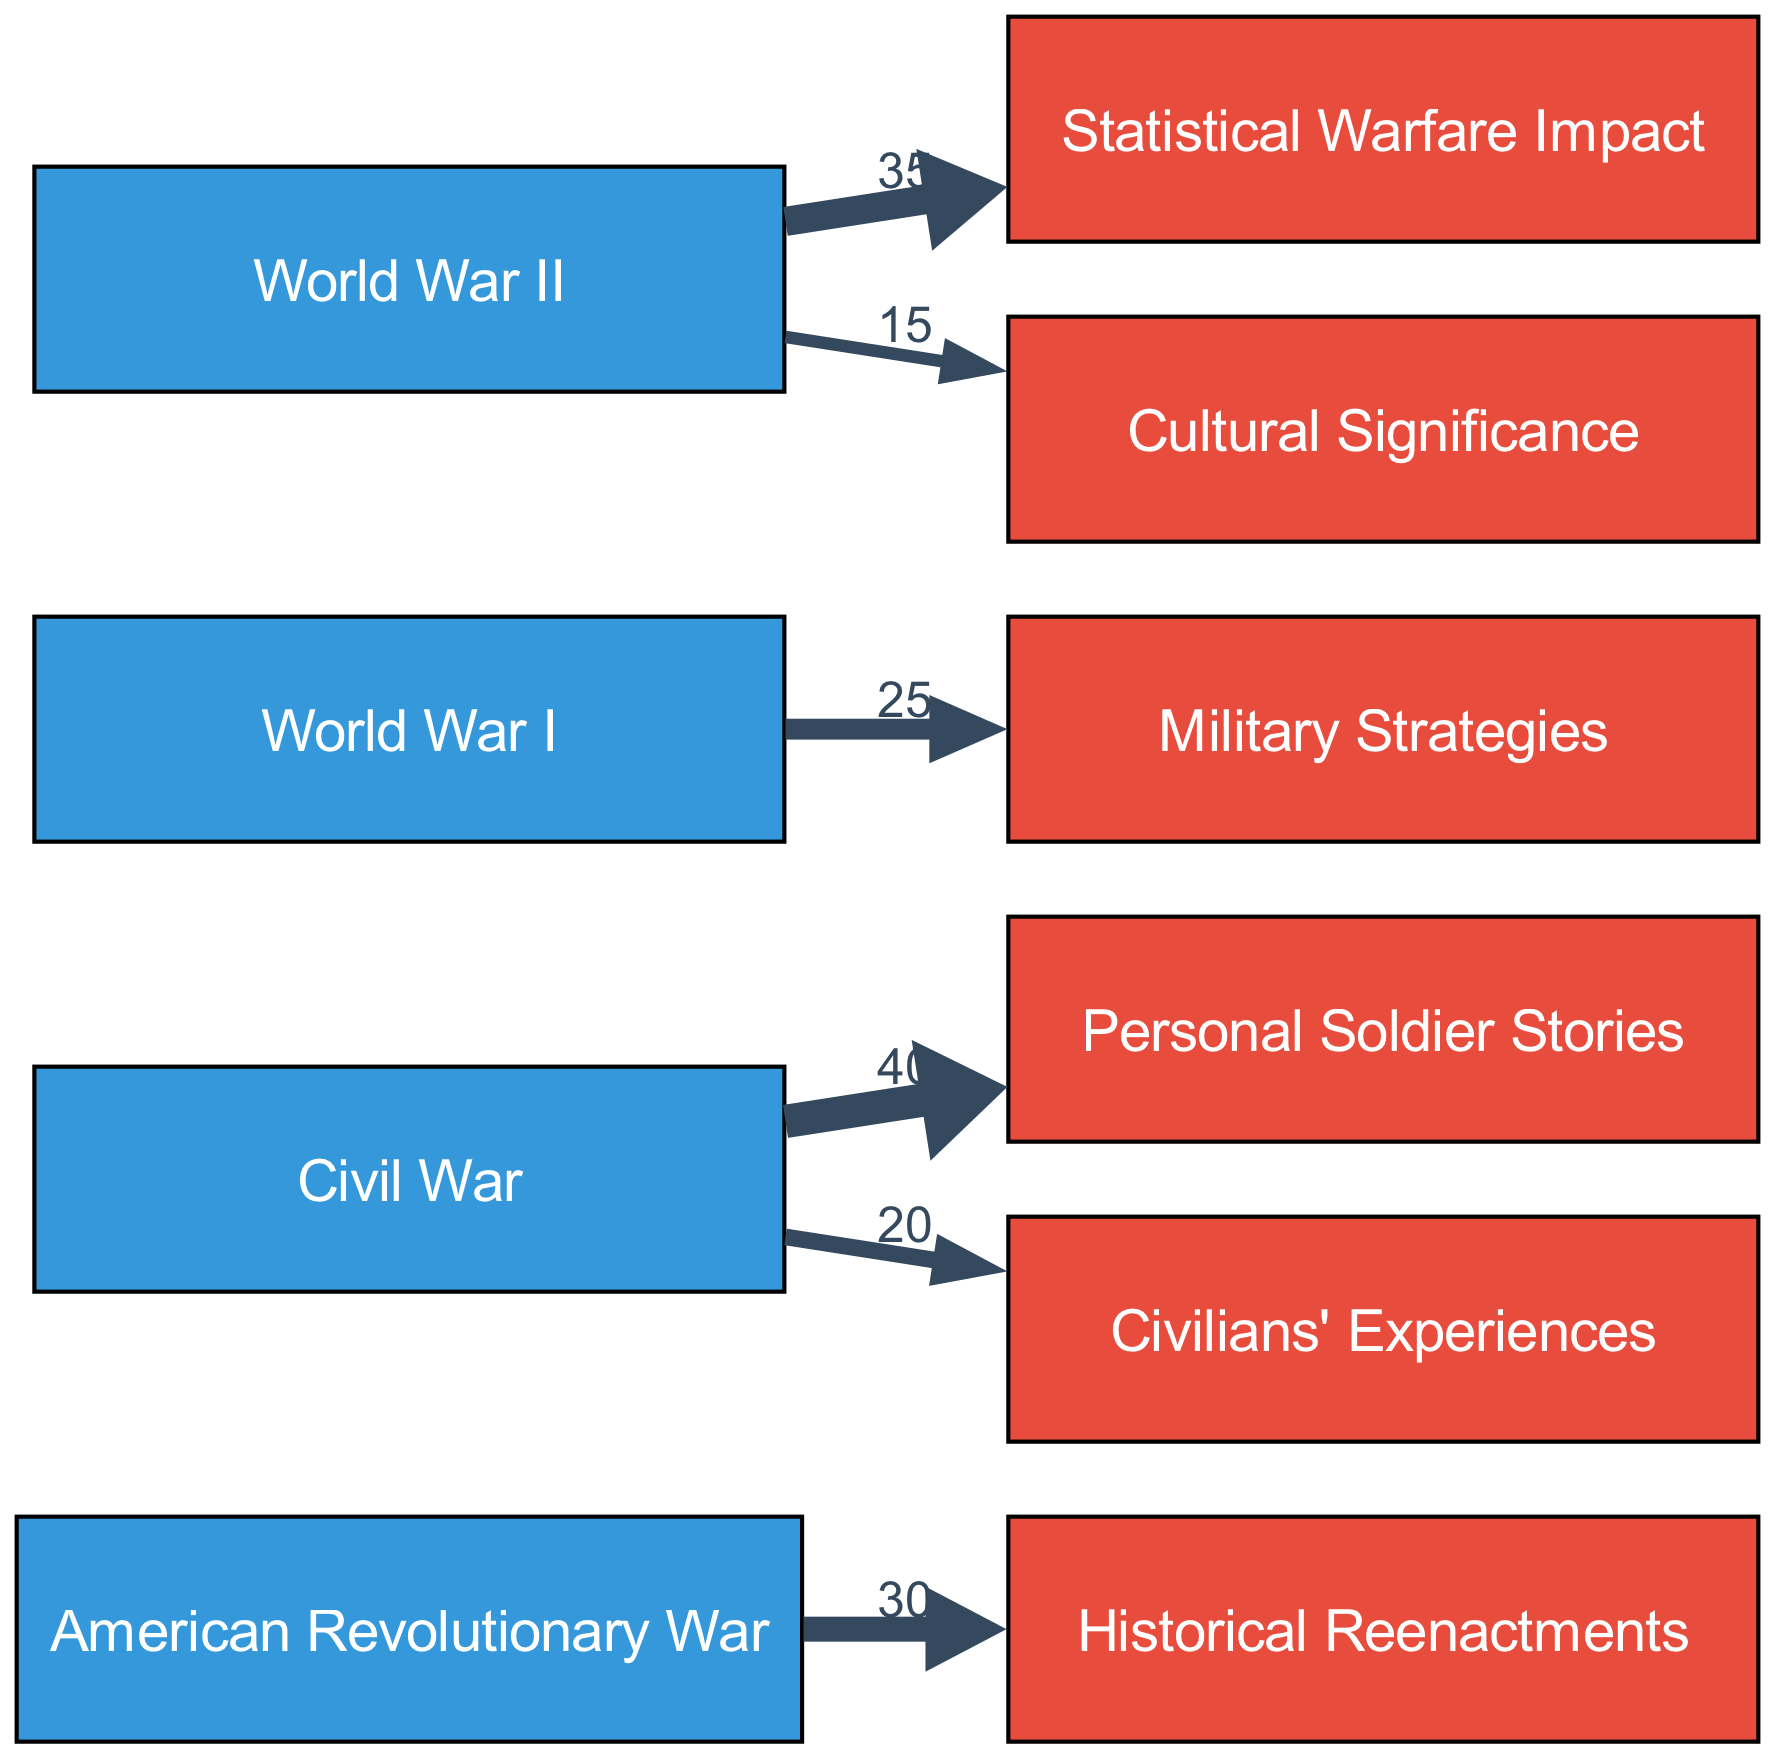What is the total number of nodes in the diagram? The diagram contains nodes for multiple events and narratives. By counting each unique entry in the "nodes" section of the data, we find there are 8 nodes total.
Answer: 8 Which narrative is linked to the Civil War event with the highest value? For the Civil War, the links indicate that the "Personal Soldier Stories" has the highest value at 40, compared to "Civilians' Experiences," which has a lower value of 20.
Answer: Personal Soldier Stories What is the value of the link between World War II and Cultural Significance? In examining the links for World War II, the link labeled with "Cultural Significance" has a value of 15.
Answer: 15 How many narratives are linked to the American Revolutionary War? Only one narrative is linked to the American Revolutionary War in the diagram, which is "Historical Reenactments." There are no other narratives connected to this event.
Answer: 1 Which event has the lowest overall narrative value? By reviewing the values connected to each event, the American Revolutionary War has a maximum value of 30 for "Historical Reenactments," while the Civil War has a combination of 60, World War I has 25, and World War II has 50, indicating that the American Revolutionary War has the lowest total narrative value.
Answer: American Revolutionary War What are the total narrative values linked to World War I? World War I links to "Military Strategies" with a value of 25. Since there is only one narrative linked to it, the total value is simply 25.
Answer: 25 What is the combined narrative value for the Civil War events? The Civil War has two narratives: "Personal Soldier Stories" at 40 and "Civilians' Experiences" at 20. Adding these together gives a total narrative value of 60 for Civil War events.
Answer: 60 Which narrative has the second highest value overall among all narratives? The narratives can be examined for their values: "Personal Soldier Stories" at 40 would be the highest, followed next by "Statistical Warfare Impact" at 35, making it the second highest.
Answer: Statistical Warfare Impact 